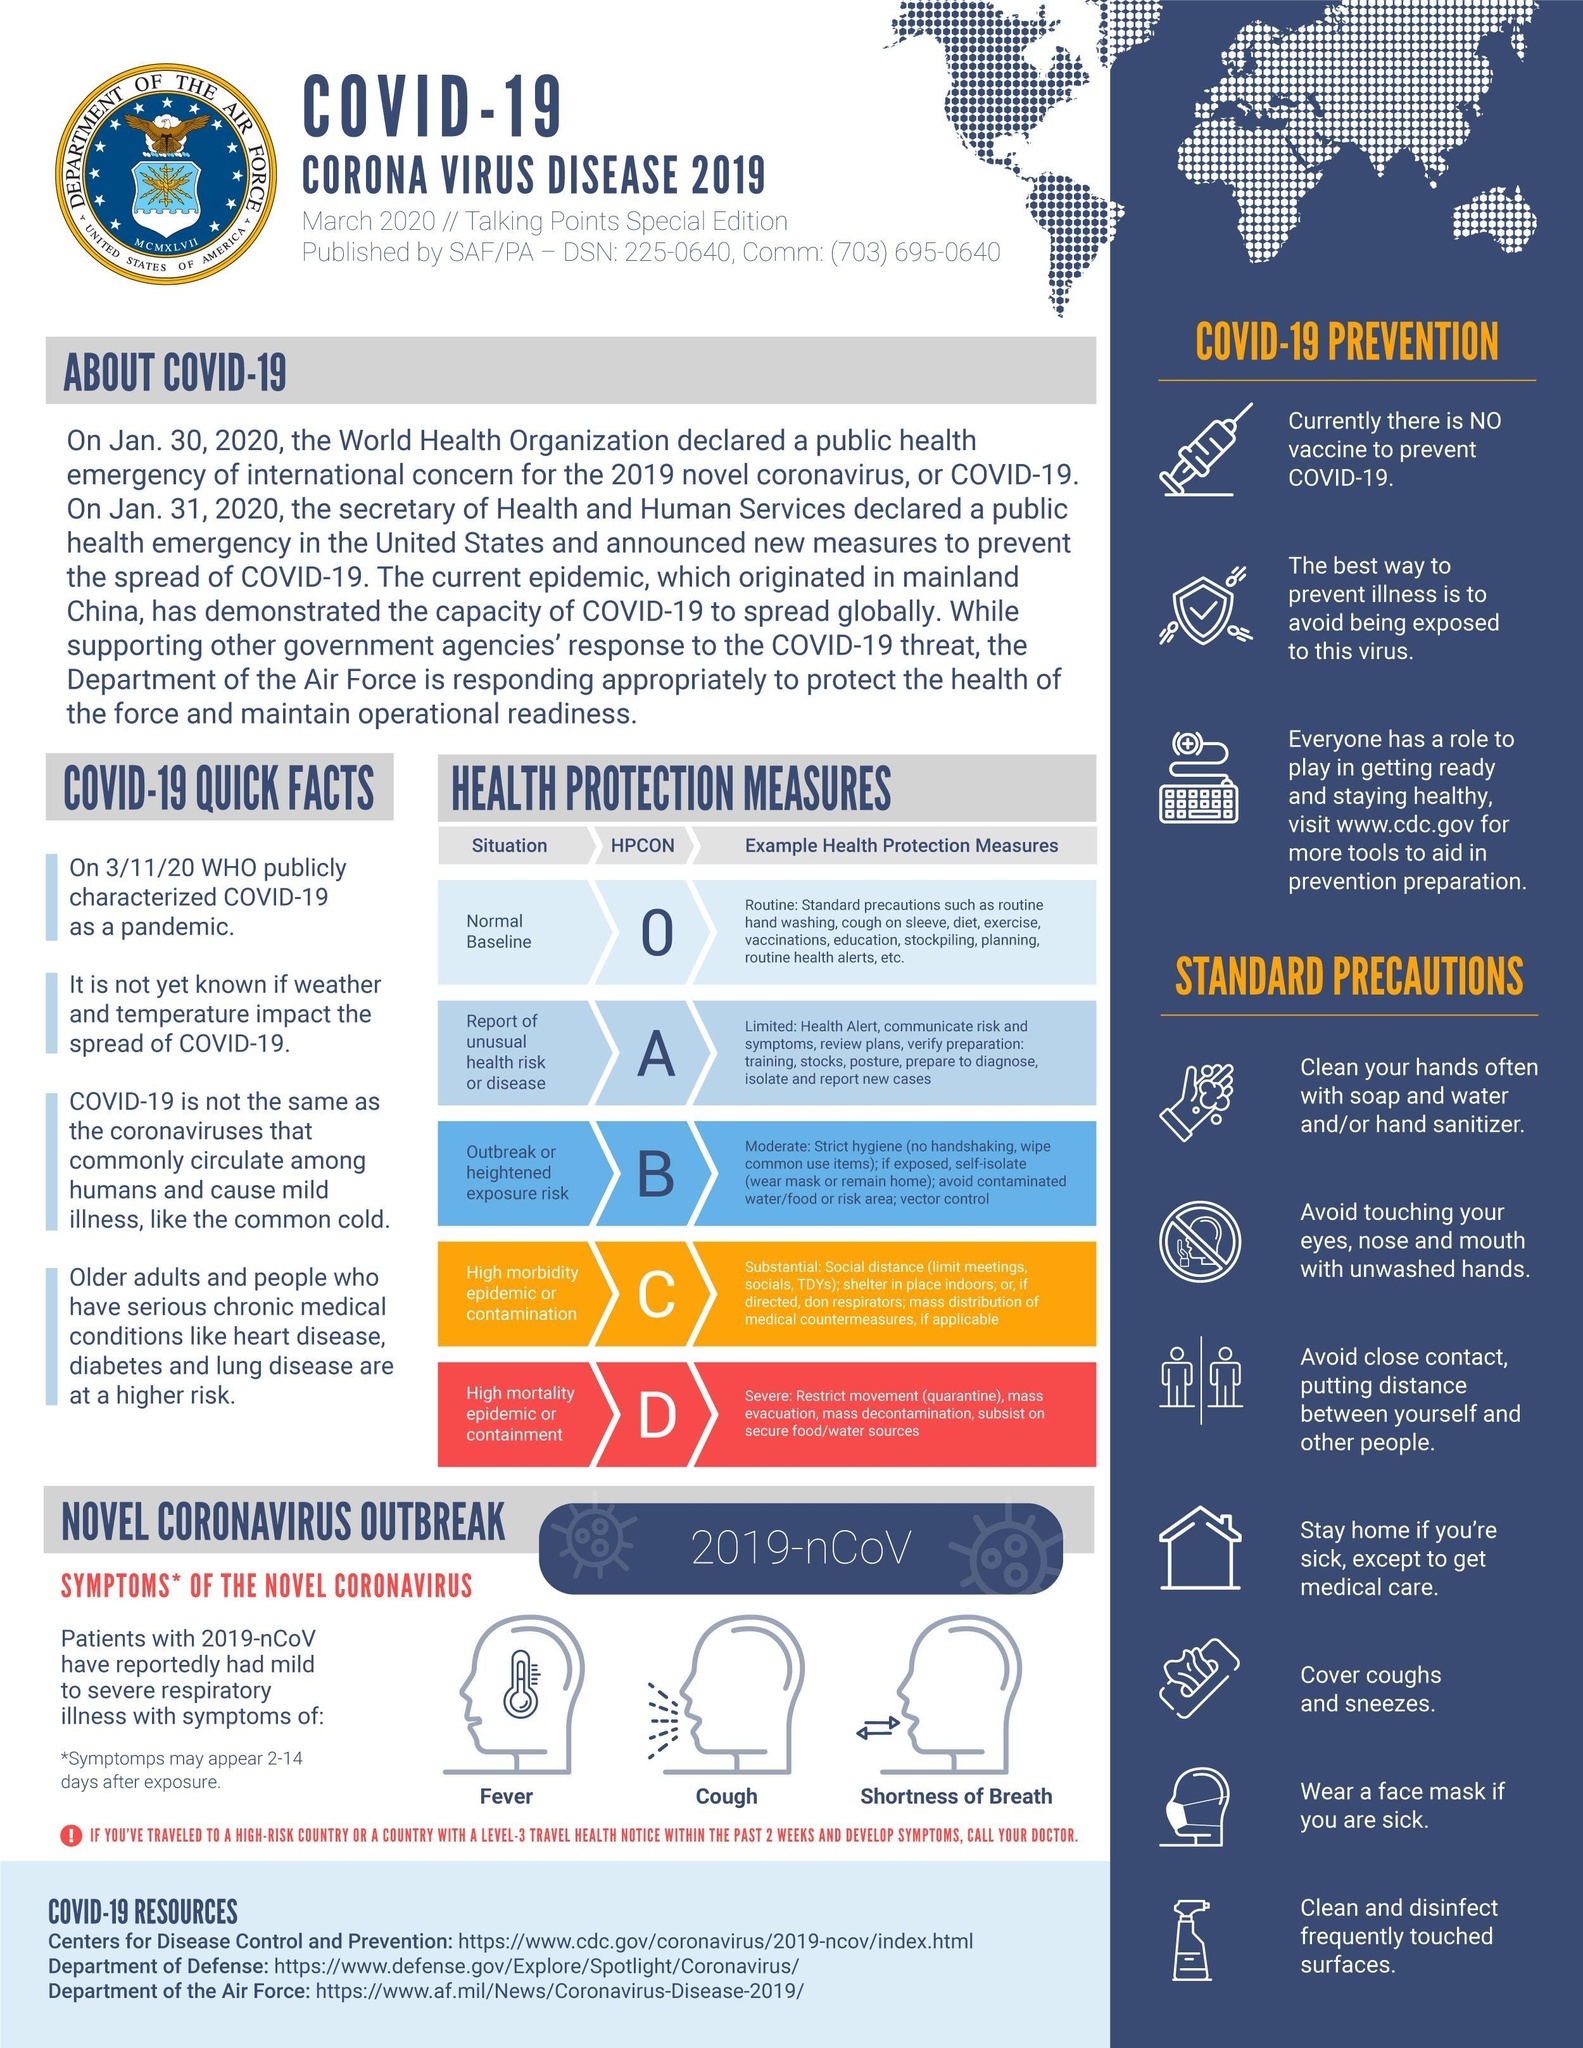What type of health protection measure is applicable for HPCON O?
Answer the question with a short phrase. Routine What is the HPCON for outbreak or heightened exposure risk? B Which parts of your face shouldn't be touched with unwashed hands? Eyes, nose and mouth What is the HPCON for high mortality epidemic or containment? D For what situation is HPCON C applicable? High morbidity epidemic or contamination What type of health protection measure is applicable for HPCON D? Severe What is the 6th standard precaution mentioned? Wear a face mask if you are sick What type of health protection measure is applicable for normal baseline? Routine How many 'standard precautions' are mentioned here? 7 What are the three symptoms that covid-19 patients are reported to have? Fever, cough, shortness of What should you use to clean your hands? Soap and water and/or hand sanitizer 